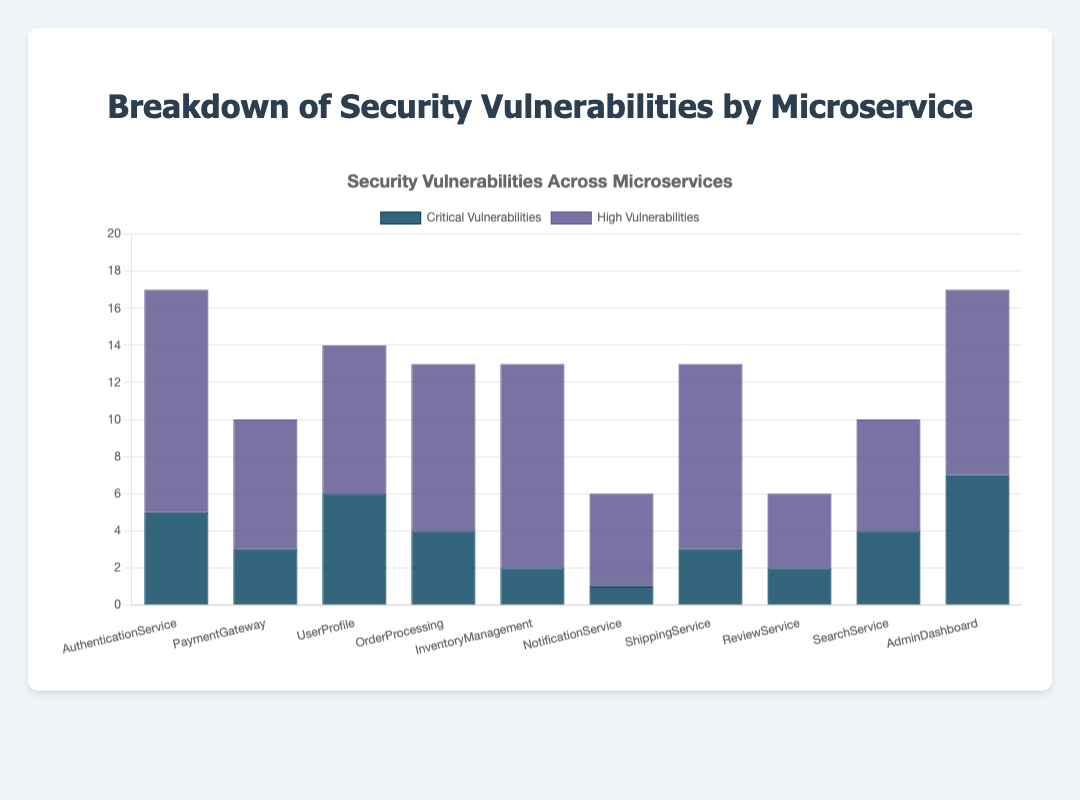Which microservice has the highest number of critical vulnerabilities? The bar for "AdminDashboard" has the highest height among the critical vulnerabilities, which indicates it has the most critical vulnerabilities.
Answer: AdminDashboard Which service has more high vulnerabilities, PaymentGateway or ShippingService? By comparing the heights of the dark blue bars for both PaymentGateway and ShippingService, ShippingService is taller, indicating more high vulnerabilities.
Answer: ShippingService What is the total number of critical vulnerabilities for both AuthenticationService and InventoryManagement combined? AuthenticationService has 5 critical vulnerabilities and InventoryManagement has 2. Summing these values gives 5 + 2 = 7.
Answer: 7 Among all the services, which one shows an equal number of critical and high vulnerabilities? Observing the lengths of the bars for each service, ReviewService has bars of the same height for both types of vulnerabilities.
Answer: ReviewService What is the combined total of high vulnerabilities for NotificationService and UserProfile? NotificationService has 5 high vulnerabilities and UserProfile has 8. Adding them together gives 5 + 8 = 13.
Answer: 13 Which microservice has the least number of critical vulnerabilities? The shortest bar among the critical vulnerabilities is for NotificationService, which indicates it has the fewest critical vulnerabilities.
Answer: NotificationService If you sum the critical vulnerabilities for UserProfile and SearchService, is the result greater than or equal to 10? UserProfile has 6 critical vulnerabilities and SearchService has 4. Summing them gives 6 + 4 = 10, which is equal to 10.
Answer: Yes How many more high vulnerabilities does AdminDashboard have compared to ReviewService? AdminDashboard has 10 high vulnerabilities while ReviewService has 4. The difference is 10 - 4 = 6.
Answer: 6 Which microservice has exactly twice the number of critical vulnerabilities as high vulnerabilities? By comparing each microservice, none of them have exactly twice the number of critical vulnerabilities compared to high vulnerabilities.
Answer: None 